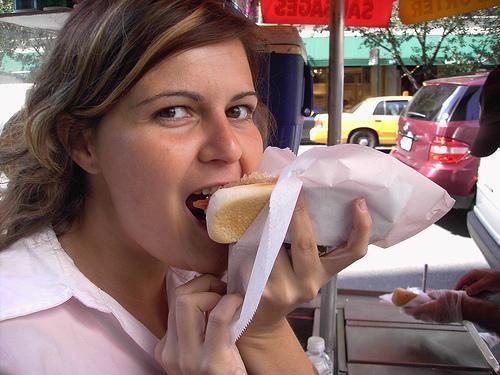How many people are shown?
Give a very brief answer. 1. How many vehicles are shown?
Give a very brief answer. 2. How many hot dogs the woman is eating?
Give a very brief answer. 1. How many yellow cars are there?
Give a very brief answer. 1. 